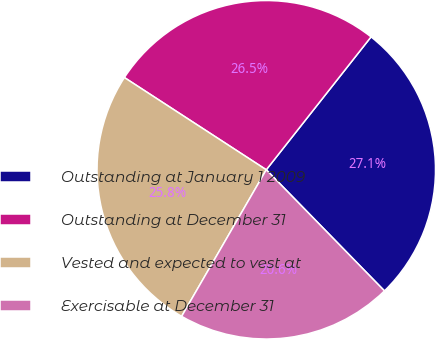Convert chart to OTSL. <chart><loc_0><loc_0><loc_500><loc_500><pie_chart><fcel>Outstanding at January 1 2009<fcel>Outstanding at December 31<fcel>Vested and expected to vest at<fcel>Exercisable at December 31<nl><fcel>27.07%<fcel>26.45%<fcel>25.84%<fcel>20.64%<nl></chart> 